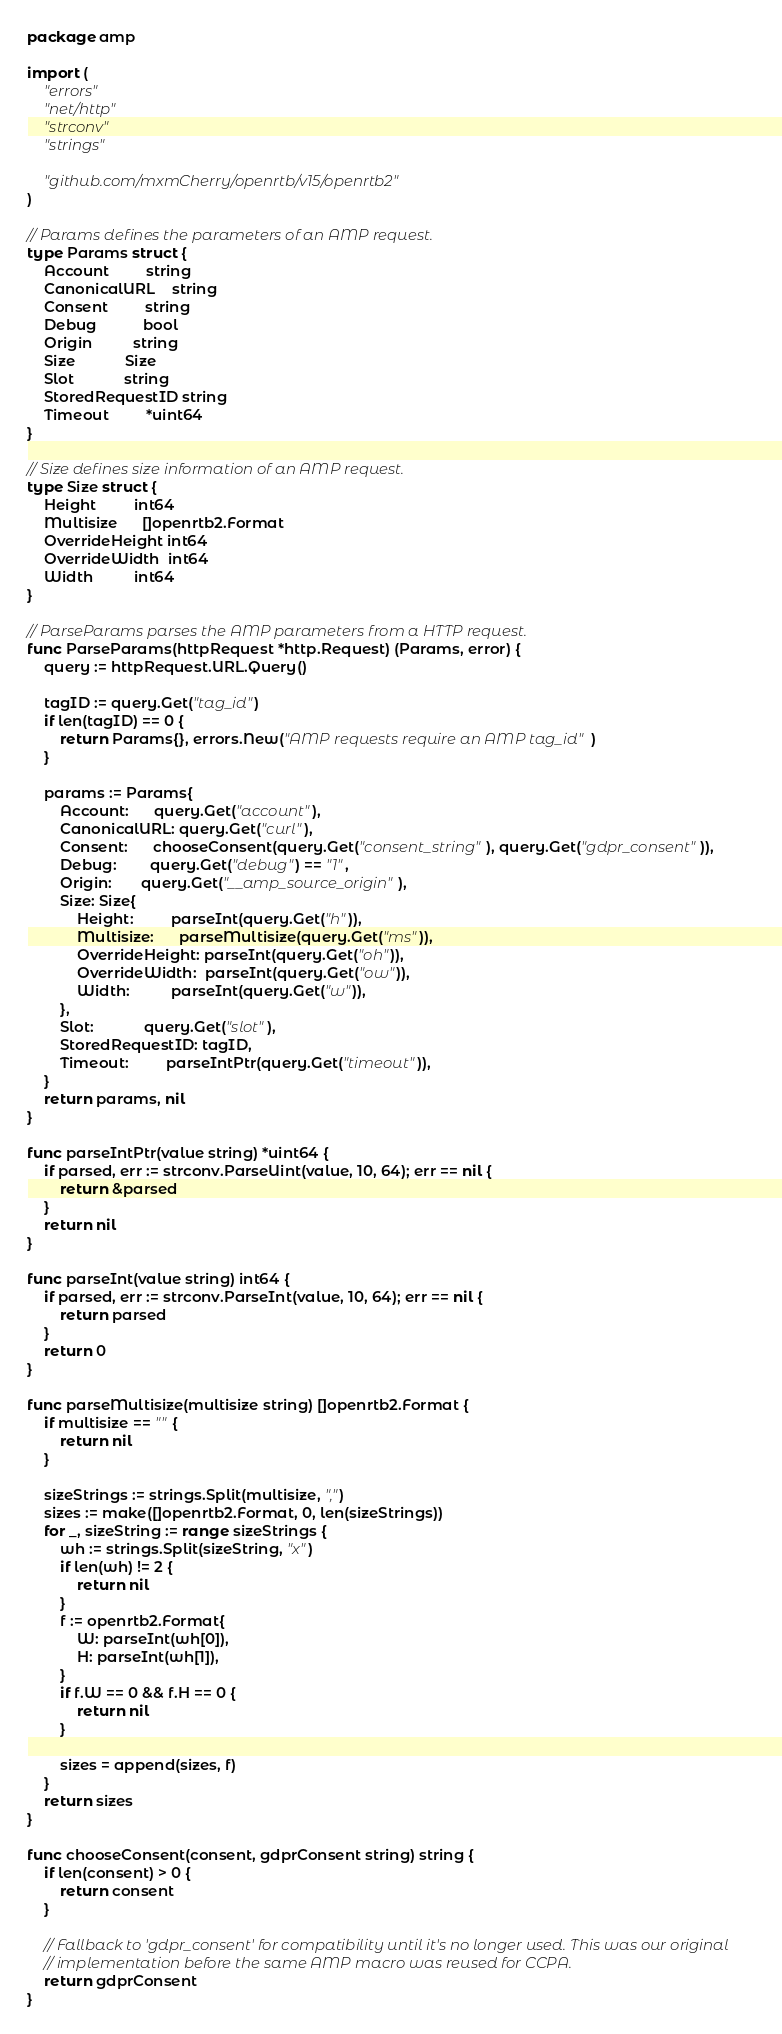<code> <loc_0><loc_0><loc_500><loc_500><_Go_>package amp

import (
	"errors"
	"net/http"
	"strconv"
	"strings"

	"github.com/mxmCherry/openrtb/v15/openrtb2"
)

// Params defines the parameters of an AMP request.
type Params struct {
	Account         string
	CanonicalURL    string
	Consent         string
	Debug           bool
	Origin          string
	Size            Size
	Slot            string
	StoredRequestID string
	Timeout         *uint64
}

// Size defines size information of an AMP request.
type Size struct {
	Height         int64
	Multisize      []openrtb2.Format
	OverrideHeight int64
	OverrideWidth  int64
	Width          int64
}

// ParseParams parses the AMP parameters from a HTTP request.
func ParseParams(httpRequest *http.Request) (Params, error) {
	query := httpRequest.URL.Query()

	tagID := query.Get("tag_id")
	if len(tagID) == 0 {
		return Params{}, errors.New("AMP requests require an AMP tag_id")
	}

	params := Params{
		Account:      query.Get("account"),
		CanonicalURL: query.Get("curl"),
		Consent:      chooseConsent(query.Get("consent_string"), query.Get("gdpr_consent")),
		Debug:        query.Get("debug") == "1",
		Origin:       query.Get("__amp_source_origin"),
		Size: Size{
			Height:         parseInt(query.Get("h")),
			Multisize:      parseMultisize(query.Get("ms")),
			OverrideHeight: parseInt(query.Get("oh")),
			OverrideWidth:  parseInt(query.Get("ow")),
			Width:          parseInt(query.Get("w")),
		},
		Slot:            query.Get("slot"),
		StoredRequestID: tagID,
		Timeout:         parseIntPtr(query.Get("timeout")),
	}
	return params, nil
}

func parseIntPtr(value string) *uint64 {
	if parsed, err := strconv.ParseUint(value, 10, 64); err == nil {
		return &parsed
	}
	return nil
}

func parseInt(value string) int64 {
	if parsed, err := strconv.ParseInt(value, 10, 64); err == nil {
		return parsed
	}
	return 0
}

func parseMultisize(multisize string) []openrtb2.Format {
	if multisize == "" {
		return nil
	}

	sizeStrings := strings.Split(multisize, ",")
	sizes := make([]openrtb2.Format, 0, len(sizeStrings))
	for _, sizeString := range sizeStrings {
		wh := strings.Split(sizeString, "x")
		if len(wh) != 2 {
			return nil
		}
		f := openrtb2.Format{
			W: parseInt(wh[0]),
			H: parseInt(wh[1]),
		}
		if f.W == 0 && f.H == 0 {
			return nil
		}

		sizes = append(sizes, f)
	}
	return sizes
}

func chooseConsent(consent, gdprConsent string) string {
	if len(consent) > 0 {
		return consent
	}

	// Fallback to 'gdpr_consent' for compatibility until it's no longer used. This was our original
	// implementation before the same AMP macro was reused for CCPA.
	return gdprConsent
}
</code> 